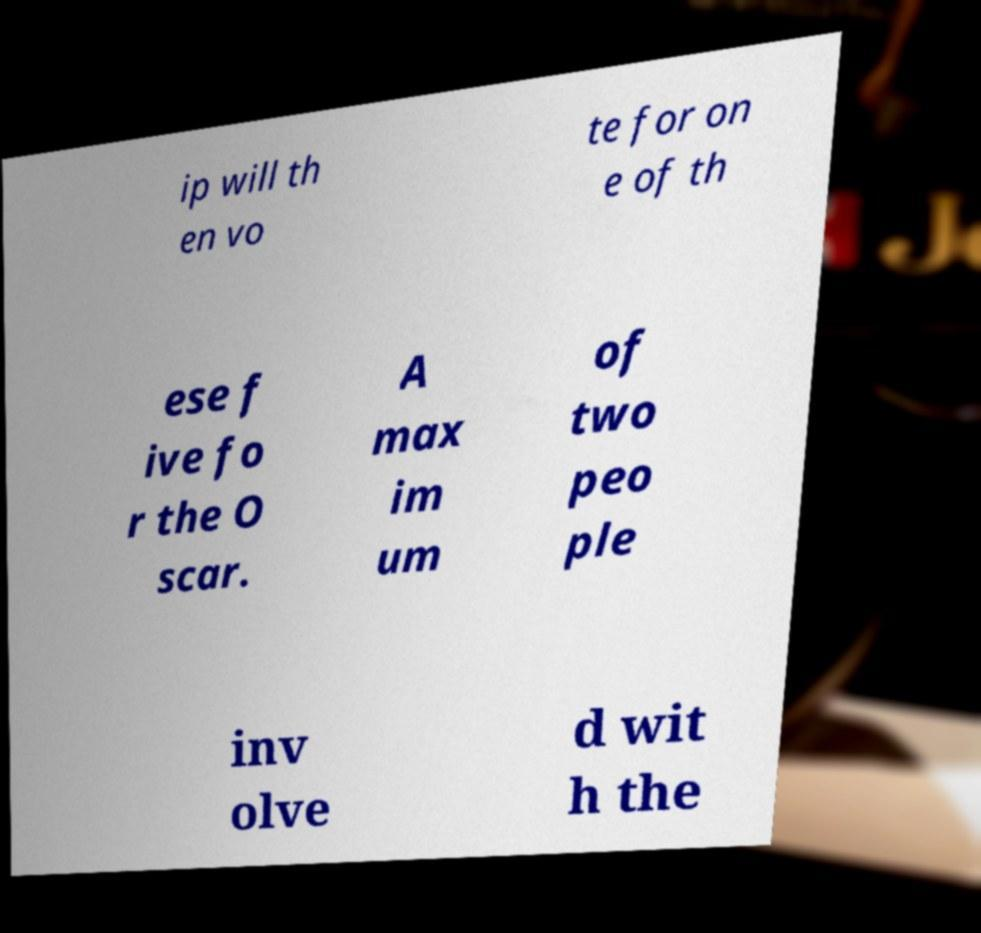Please read and relay the text visible in this image. What does it say? ip will th en vo te for on e of th ese f ive fo r the O scar. A max im um of two peo ple inv olve d wit h the 